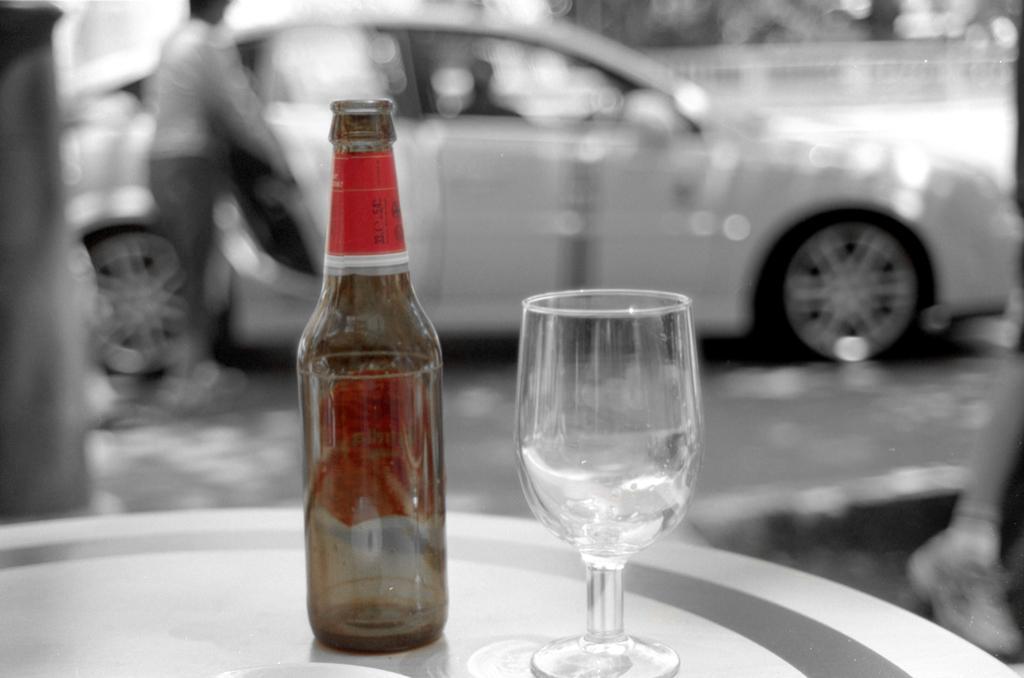Describe this image in one or two sentences. In this picture we can see a empty bottle and a empty glass which is placed on a table, in the background we can see a man and there is a car, we can see a shoe on the right side of the image. 